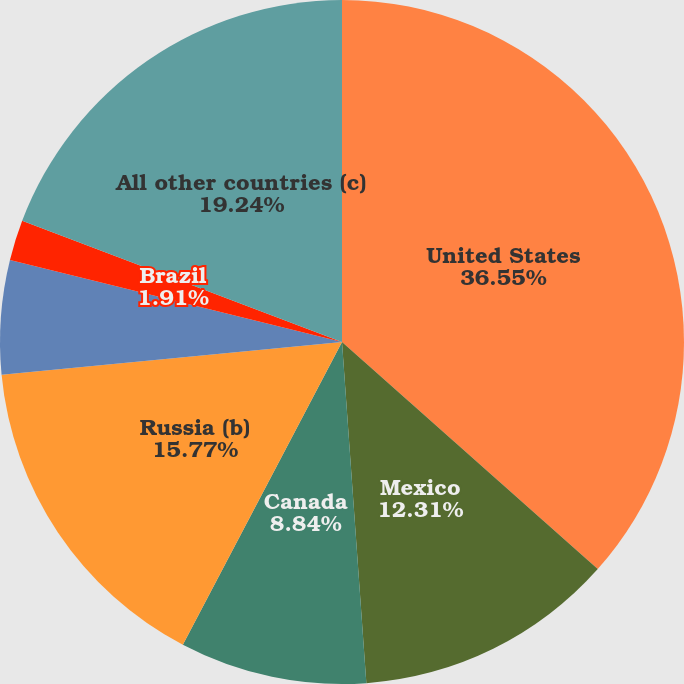<chart> <loc_0><loc_0><loc_500><loc_500><pie_chart><fcel>United States<fcel>Mexico<fcel>Canada<fcel>Russia (b)<fcel>United Kingdom<fcel>Brazil<fcel>All other countries (c)<nl><fcel>36.56%<fcel>12.31%<fcel>8.84%<fcel>15.77%<fcel>5.38%<fcel>1.91%<fcel>19.24%<nl></chart> 